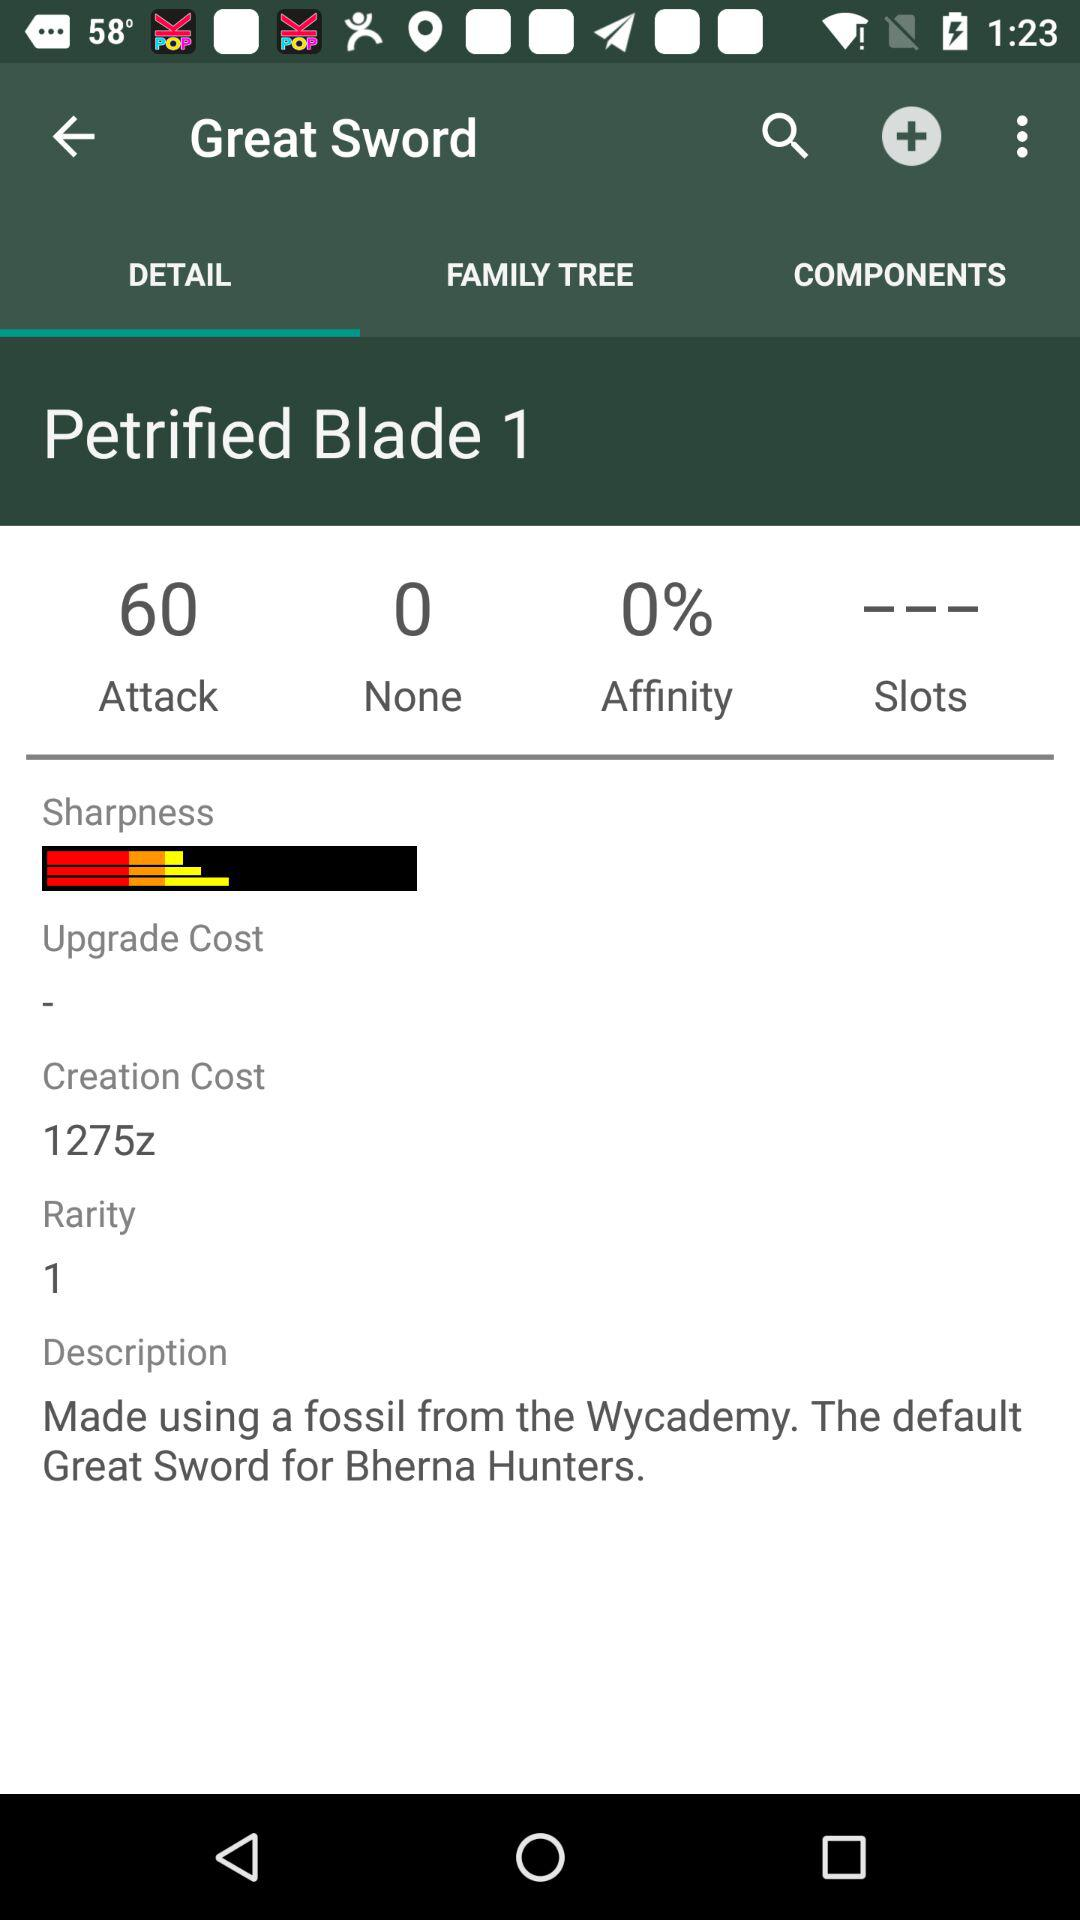How many attack points can the "Great Sword" inflict? The "Great Sword" can inflict 60 attack points. 